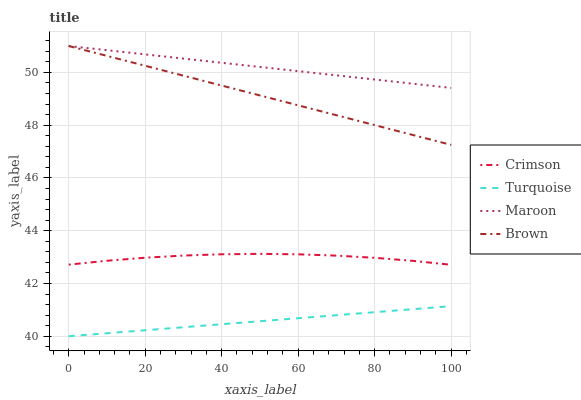Does Turquoise have the minimum area under the curve?
Answer yes or no. Yes. Does Maroon have the maximum area under the curve?
Answer yes or no. Yes. Does Brown have the minimum area under the curve?
Answer yes or no. No. Does Brown have the maximum area under the curve?
Answer yes or no. No. Is Maroon the smoothest?
Answer yes or no. Yes. Is Crimson the roughest?
Answer yes or no. Yes. Is Brown the smoothest?
Answer yes or no. No. Is Brown the roughest?
Answer yes or no. No. Does Turquoise have the lowest value?
Answer yes or no. Yes. Does Brown have the lowest value?
Answer yes or no. No. Does Maroon have the highest value?
Answer yes or no. Yes. Does Turquoise have the highest value?
Answer yes or no. No. Is Turquoise less than Brown?
Answer yes or no. Yes. Is Brown greater than Crimson?
Answer yes or no. Yes. Does Maroon intersect Brown?
Answer yes or no. Yes. Is Maroon less than Brown?
Answer yes or no. No. Is Maroon greater than Brown?
Answer yes or no. No. Does Turquoise intersect Brown?
Answer yes or no. No. 